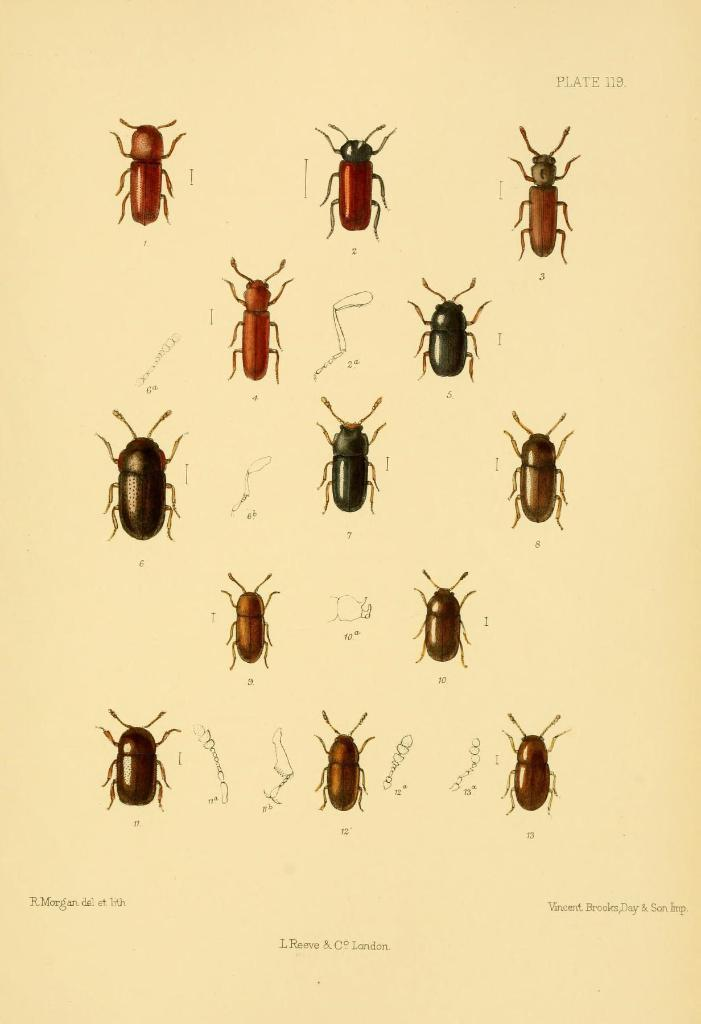What type of creatures are depicted in the graphical images in the image? There are graphical images of insects in the image. What else can be found on the image besides the insects? There is text written on the image. What type of curtain is hanging in the background of the image? There is no curtain present in the image; it only contains graphical images of insects and text. 